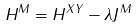Convert formula to latex. <formula><loc_0><loc_0><loc_500><loc_500>H ^ { M } = H ^ { X Y } - \lambda J ^ { M }</formula> 